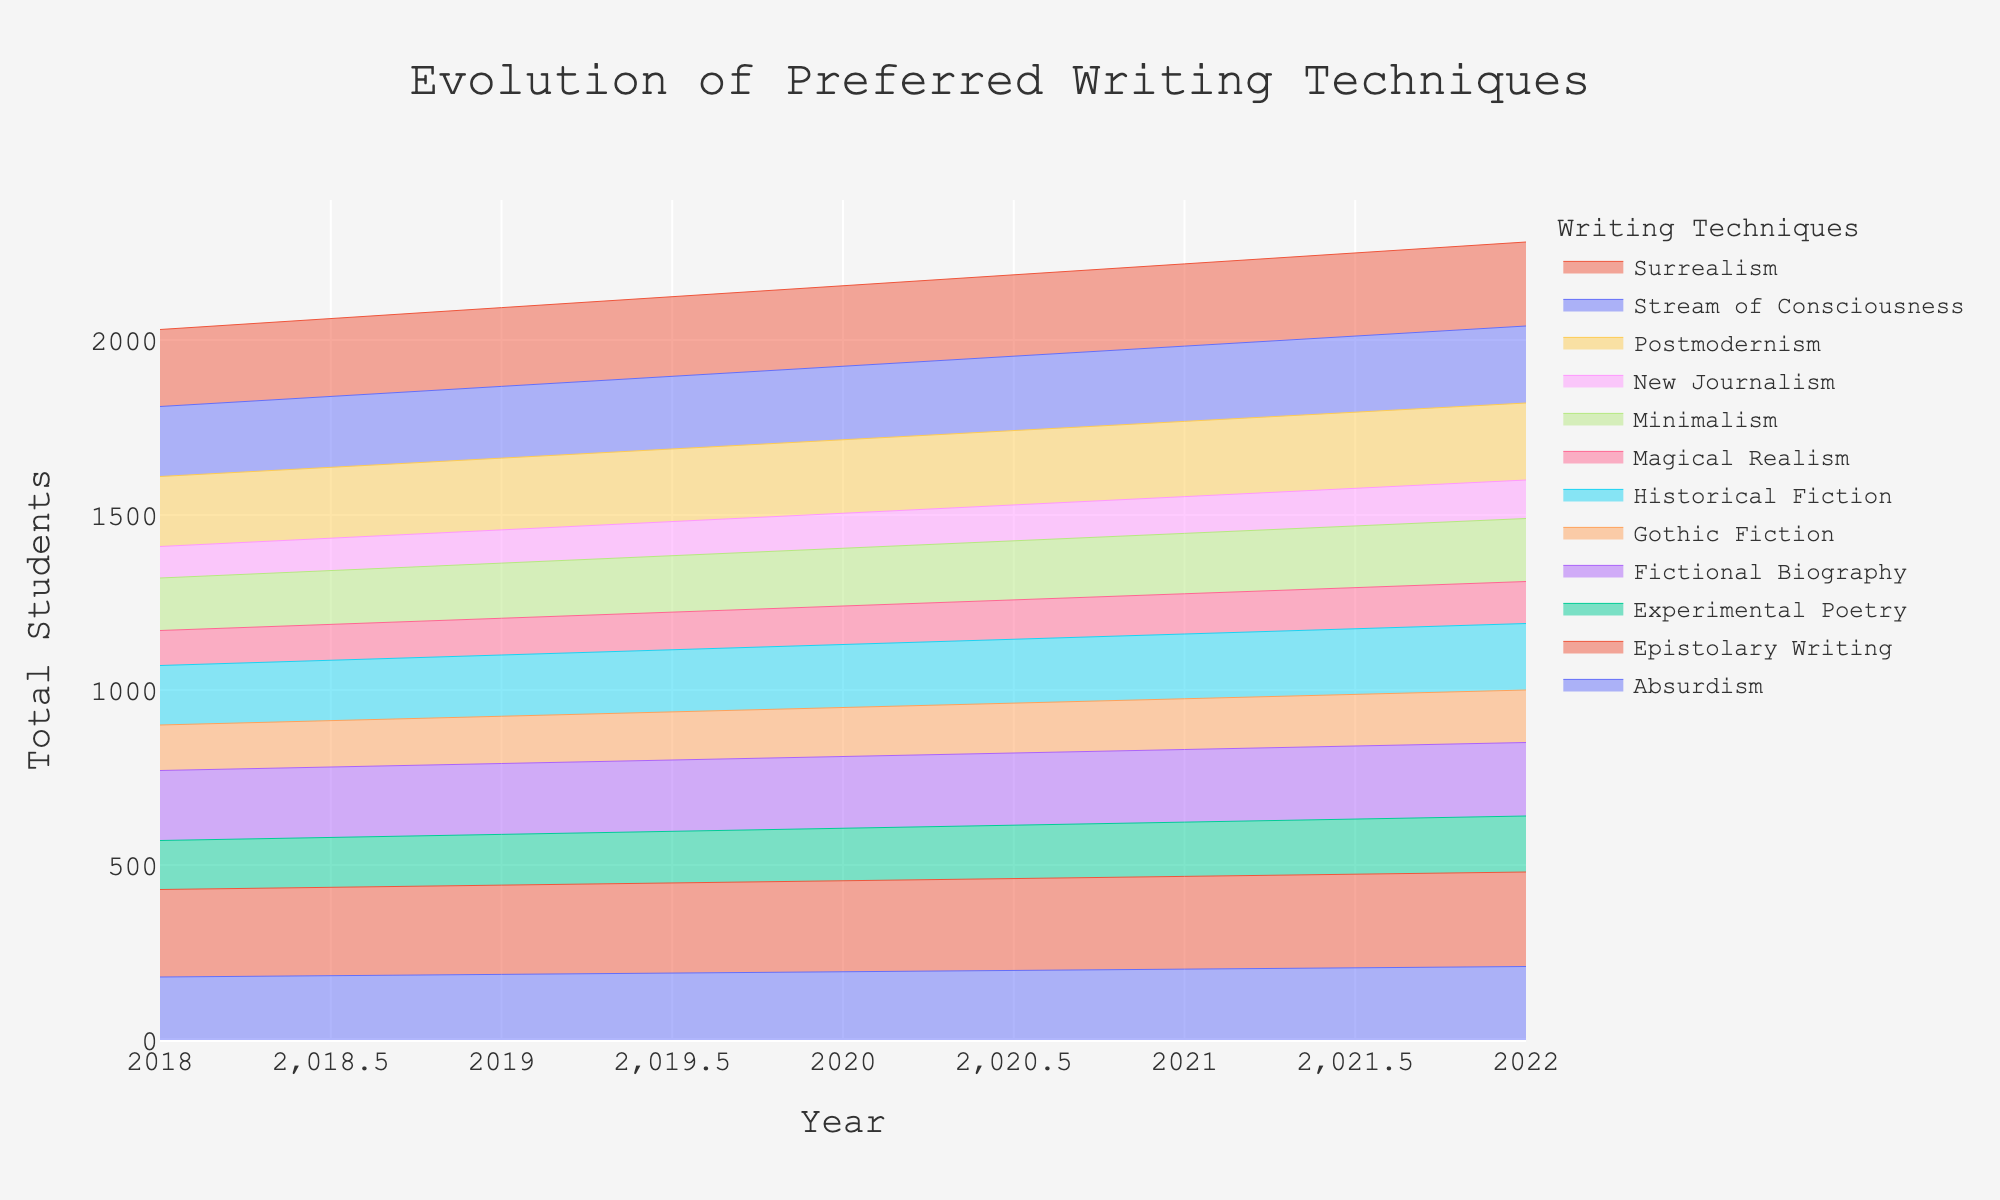What is the title of the figure? The title of the figure is typically placed at the top and clearly indicated to describe what the figure represents. Here, it's located centrally at the top.
Answer: Evolution of Preferred Writing Techniques How many preferred writing techniques are represented in the figure? Each technique is shown as a distinct color-filled area within the streamgraph. A quick count based on the legend will provide the answer.
Answer: 10 Which year shows a higher total number of students, 2018 or 2022? By examining the height of the stacked areas in each year along the y-axis, we can see which year reaches a higher point, implying a greater total number of students.
Answer: 2022 In which year did "Stream of Consciousness" writing technique have more students? Look at the sections representing "Stream of Consciousness" for both 2018 and 2022 and compare their heights.
Answer: 2022 What is the general trend for the "Magical Realism" technique from 2018 to 2022? Examine the area corresponding to "Magical Realism" and observe whether it increases, decreases, or remains stable over the years.
Answer: Increasing Which writing technique has grown the most from 2018 to 2022? To determine the most growth, compare the size of each area from 2018 to 2022 and identify which one has expanded the most.
Answer: Epistolary Writing What trend can be observed for "New Journalism" from 2018 to 2022? Like other areas, observe the size of the "New Journalism" area at both years and note if it grows, shrinks, or stays constant.
Answer: Increasing Is there any writing technique that remained constant in student numbers from 2018 to 2022? No area should have an unchanged height between these two years. Scan for any technique with consistent area size throughout the years.
Answer: No Which writing technique had the least number of students in 2022? The smallest area segment corresponding to 2022 will indicate the least popular writing technique that year.
Answer: Absurdism Comparing "Surrealism" and "Minimalism", which technique had more students in 2022? By observing the height of the areas representing these techniques in 2022, we can identify which one had more students.
Answer: Surrealism 